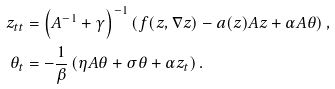Convert formula to latex. <formula><loc_0><loc_0><loc_500><loc_500>z _ { t t } & = \left ( A ^ { - 1 } + \gamma \right ) ^ { - 1 } \left ( f ( z , \nabla z ) - a ( z ) A z + \alpha A \theta \right ) , \\ \theta _ { t } & = - \frac { 1 } { \beta } \left ( \eta A \theta + \sigma \theta + \alpha z _ { t } \right ) .</formula> 